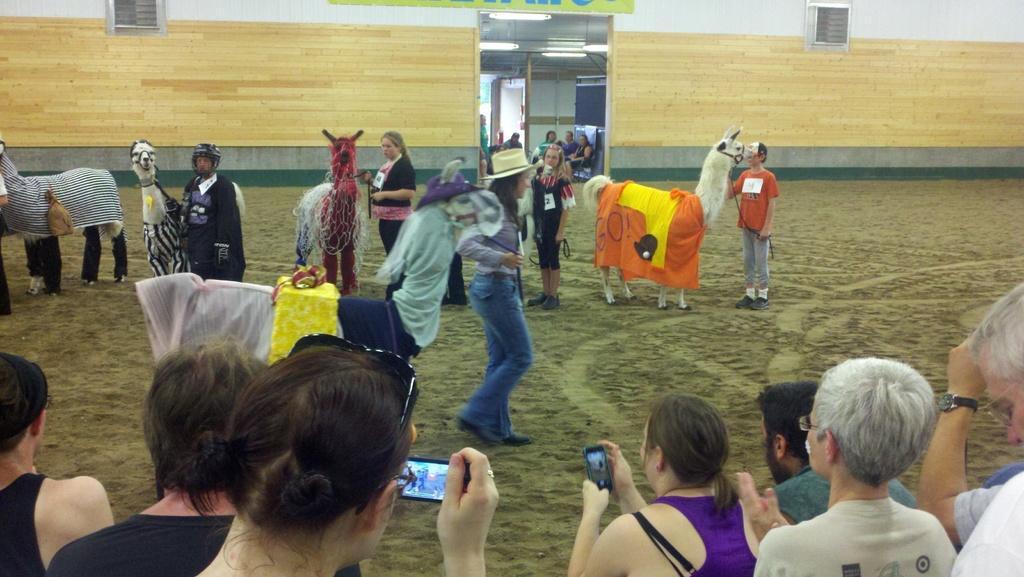How would you summarize this image in a sentence or two? In this image in the front there are persons standing and holding mobile phones in there hands. In the center there are persons standing and there are animals. In the background there is a wall and there are windows and there are persons sitting. 